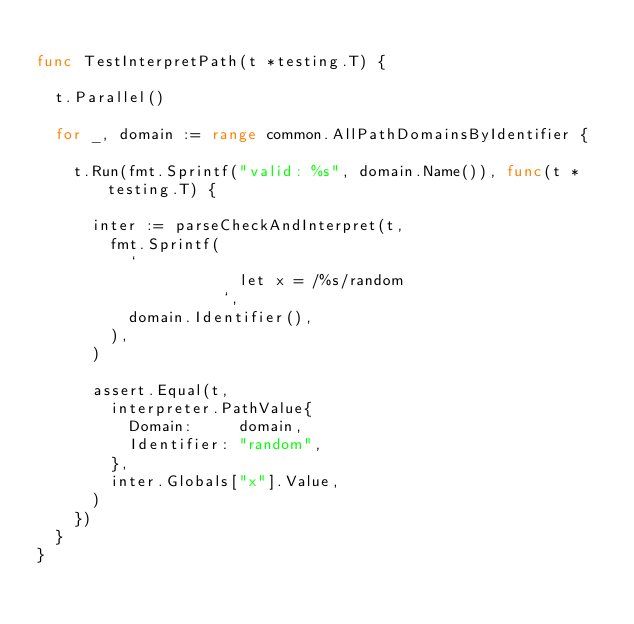<code> <loc_0><loc_0><loc_500><loc_500><_Go_>
func TestInterpretPath(t *testing.T) {

	t.Parallel()

	for _, domain := range common.AllPathDomainsByIdentifier {

		t.Run(fmt.Sprintf("valid: %s", domain.Name()), func(t *testing.T) {

			inter := parseCheckAndInterpret(t,
				fmt.Sprintf(
					`
                      let x = /%s/random
                    `,
					domain.Identifier(),
				),
			)

			assert.Equal(t,
				interpreter.PathValue{
					Domain:     domain,
					Identifier: "random",
				},
				inter.Globals["x"].Value,
			)
		})
	}
}
</code> 